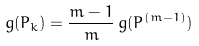<formula> <loc_0><loc_0><loc_500><loc_500>g ( P _ { k } ) = \frac { m - 1 } { m } \, g ( P ^ { ( m - 1 ) } )</formula> 